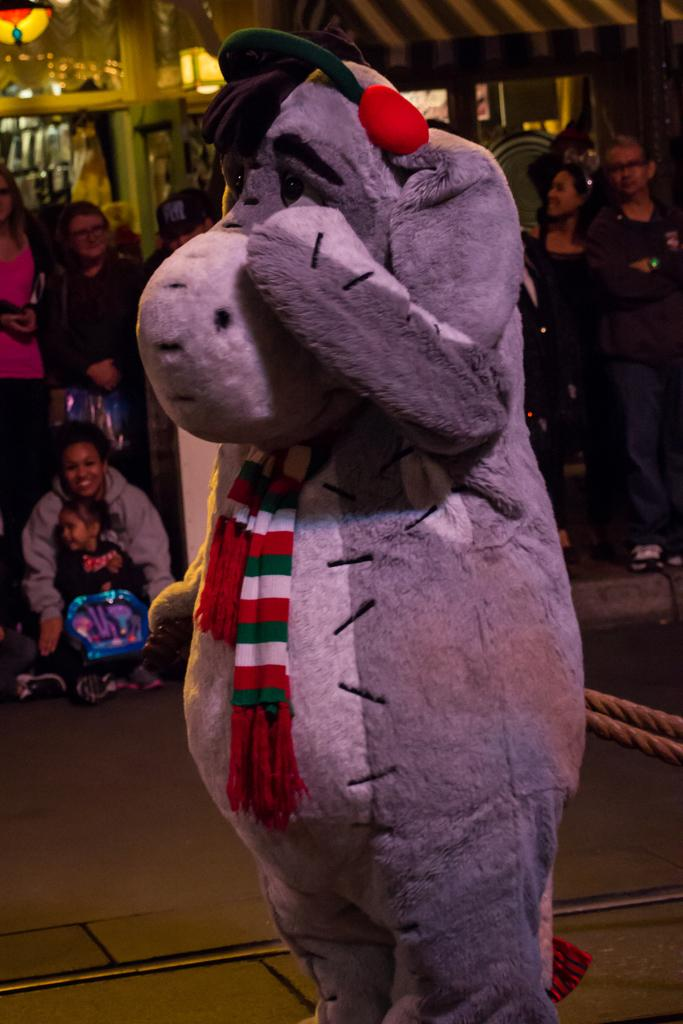What is the person in the image wearing? The person in the image is wearing an animal costume. How many people are present in the image? There are many people present in the image. Can you describe any additional features in the image? There may be lights present on the roof in the image. How does the person in the animal costume manage to smash the slope in the image? There is no slope present in the image, and the person in the animal costume is not shown performing any action that would involve smashing anything. 